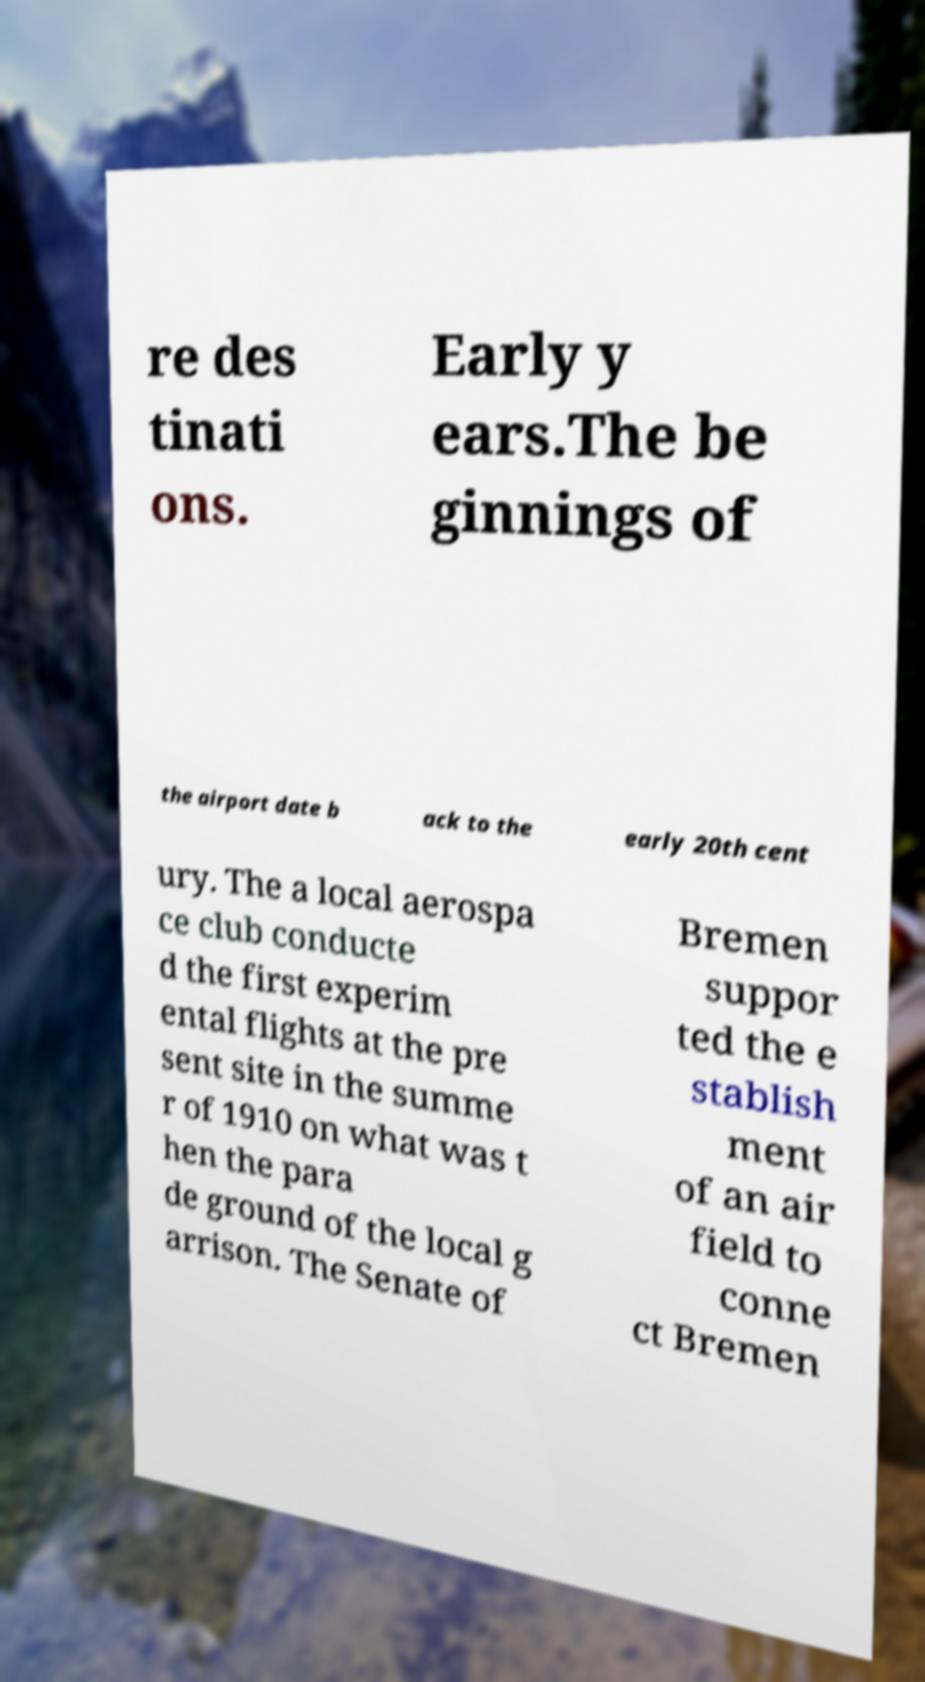Please identify and transcribe the text found in this image. re des tinati ons. Early y ears.The be ginnings of the airport date b ack to the early 20th cent ury. The a local aerospa ce club conducte d the first experim ental flights at the pre sent site in the summe r of 1910 on what was t hen the para de ground of the local g arrison. The Senate of Bremen suppor ted the e stablish ment of an air field to conne ct Bremen 